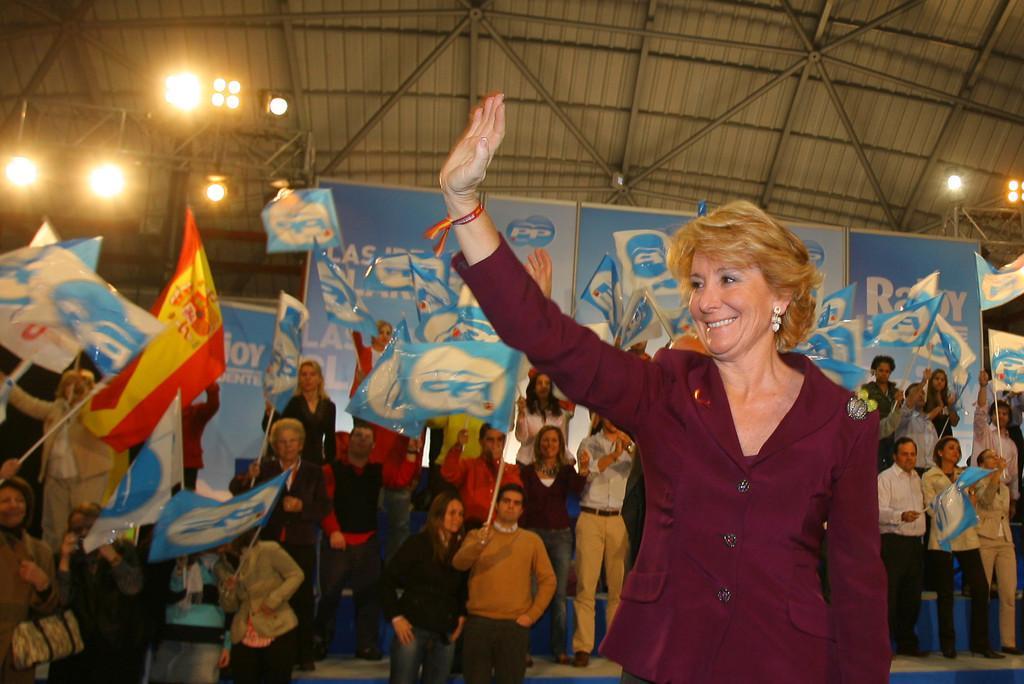Can you describe this image briefly? On the right side of the image we can see a lady standing. In the background there are people holding flags in their hands. We can see boards. At the top there are lights. 